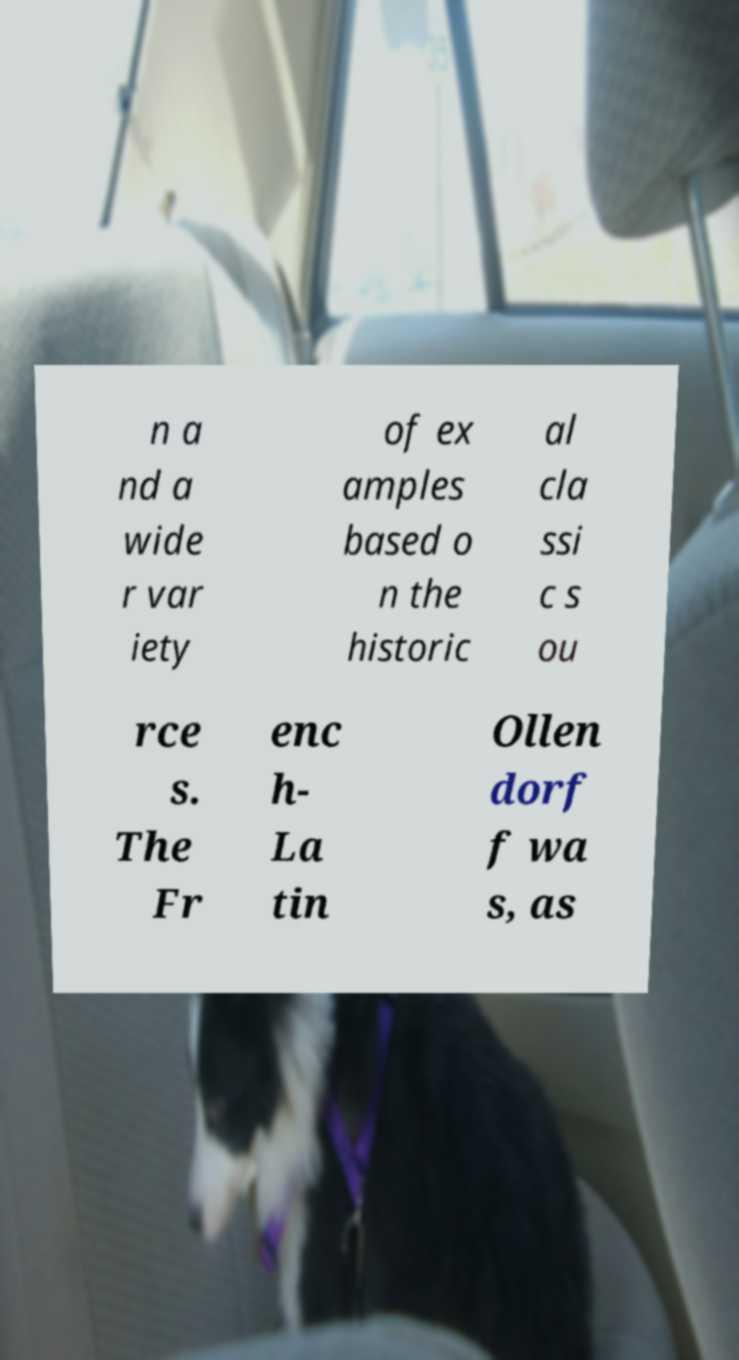Could you extract and type out the text from this image? n a nd a wide r var iety of ex amples based o n the historic al cla ssi c s ou rce s. The Fr enc h- La tin Ollen dorf f wa s, as 